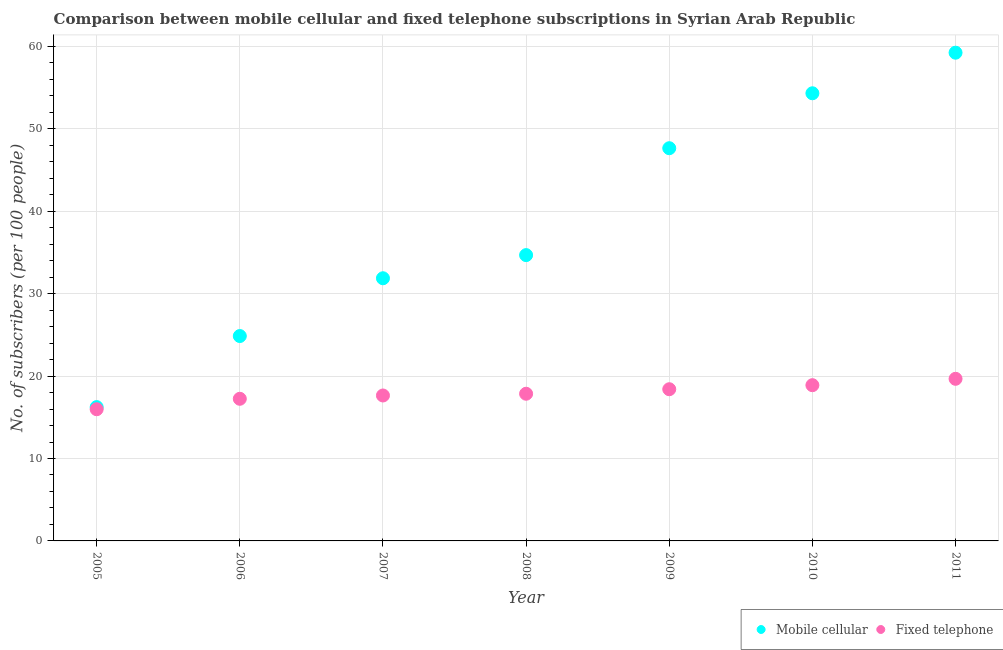How many different coloured dotlines are there?
Keep it short and to the point. 2. What is the number of mobile cellular subscribers in 2009?
Offer a terse response. 47.65. Across all years, what is the maximum number of mobile cellular subscribers?
Offer a terse response. 59.24. Across all years, what is the minimum number of mobile cellular subscribers?
Your answer should be very brief. 16.24. In which year was the number of mobile cellular subscribers maximum?
Your answer should be compact. 2011. In which year was the number of mobile cellular subscribers minimum?
Your response must be concise. 2005. What is the total number of mobile cellular subscribers in the graph?
Make the answer very short. 268.86. What is the difference between the number of mobile cellular subscribers in 2005 and that in 2006?
Your answer should be very brief. -8.62. What is the difference between the number of mobile cellular subscribers in 2011 and the number of fixed telephone subscribers in 2010?
Offer a terse response. 40.34. What is the average number of fixed telephone subscribers per year?
Offer a terse response. 17.96. In the year 2007, what is the difference between the number of mobile cellular subscribers and number of fixed telephone subscribers?
Keep it short and to the point. 14.23. What is the ratio of the number of mobile cellular subscribers in 2008 to that in 2010?
Give a very brief answer. 0.64. Is the number of fixed telephone subscribers in 2006 less than that in 2007?
Give a very brief answer. Yes. Is the difference between the number of mobile cellular subscribers in 2007 and 2009 greater than the difference between the number of fixed telephone subscribers in 2007 and 2009?
Keep it short and to the point. No. What is the difference between the highest and the second highest number of fixed telephone subscribers?
Offer a very short reply. 0.77. What is the difference between the highest and the lowest number of mobile cellular subscribers?
Provide a short and direct response. 43. Does the number of fixed telephone subscribers monotonically increase over the years?
Ensure brevity in your answer.  Yes. How many dotlines are there?
Keep it short and to the point. 2. How many years are there in the graph?
Provide a succinct answer. 7. Where does the legend appear in the graph?
Offer a terse response. Bottom right. What is the title of the graph?
Offer a very short reply. Comparison between mobile cellular and fixed telephone subscriptions in Syrian Arab Republic. Does "Agricultural land" appear as one of the legend labels in the graph?
Keep it short and to the point. No. What is the label or title of the Y-axis?
Make the answer very short. No. of subscribers (per 100 people). What is the No. of subscribers (per 100 people) of Mobile cellular in 2005?
Offer a terse response. 16.24. What is the No. of subscribers (per 100 people) in Fixed telephone in 2005?
Offer a terse response. 15.98. What is the No. of subscribers (per 100 people) of Mobile cellular in 2006?
Provide a succinct answer. 24.86. What is the No. of subscribers (per 100 people) of Fixed telephone in 2006?
Your answer should be very brief. 17.25. What is the No. of subscribers (per 100 people) of Mobile cellular in 2007?
Keep it short and to the point. 31.87. What is the No. of subscribers (per 100 people) in Fixed telephone in 2007?
Your answer should be compact. 17.65. What is the No. of subscribers (per 100 people) of Mobile cellular in 2008?
Your response must be concise. 34.68. What is the No. of subscribers (per 100 people) of Fixed telephone in 2008?
Give a very brief answer. 17.86. What is the No. of subscribers (per 100 people) in Mobile cellular in 2009?
Keep it short and to the point. 47.65. What is the No. of subscribers (per 100 people) of Fixed telephone in 2009?
Offer a very short reply. 18.41. What is the No. of subscribers (per 100 people) in Mobile cellular in 2010?
Ensure brevity in your answer.  54.32. What is the No. of subscribers (per 100 people) in Fixed telephone in 2010?
Your answer should be compact. 18.9. What is the No. of subscribers (per 100 people) in Mobile cellular in 2011?
Provide a succinct answer. 59.24. What is the No. of subscribers (per 100 people) of Fixed telephone in 2011?
Ensure brevity in your answer.  19.67. Across all years, what is the maximum No. of subscribers (per 100 people) of Mobile cellular?
Your response must be concise. 59.24. Across all years, what is the maximum No. of subscribers (per 100 people) in Fixed telephone?
Ensure brevity in your answer.  19.67. Across all years, what is the minimum No. of subscribers (per 100 people) in Mobile cellular?
Provide a short and direct response. 16.24. Across all years, what is the minimum No. of subscribers (per 100 people) in Fixed telephone?
Ensure brevity in your answer.  15.98. What is the total No. of subscribers (per 100 people) in Mobile cellular in the graph?
Your answer should be very brief. 268.86. What is the total No. of subscribers (per 100 people) in Fixed telephone in the graph?
Offer a terse response. 125.7. What is the difference between the No. of subscribers (per 100 people) in Mobile cellular in 2005 and that in 2006?
Ensure brevity in your answer.  -8.62. What is the difference between the No. of subscribers (per 100 people) of Fixed telephone in 2005 and that in 2006?
Provide a succinct answer. -1.27. What is the difference between the No. of subscribers (per 100 people) in Mobile cellular in 2005 and that in 2007?
Your answer should be compact. -15.63. What is the difference between the No. of subscribers (per 100 people) in Fixed telephone in 2005 and that in 2007?
Offer a terse response. -1.67. What is the difference between the No. of subscribers (per 100 people) of Mobile cellular in 2005 and that in 2008?
Offer a terse response. -18.44. What is the difference between the No. of subscribers (per 100 people) in Fixed telephone in 2005 and that in 2008?
Provide a short and direct response. -1.88. What is the difference between the No. of subscribers (per 100 people) of Mobile cellular in 2005 and that in 2009?
Offer a very short reply. -31.41. What is the difference between the No. of subscribers (per 100 people) in Fixed telephone in 2005 and that in 2009?
Give a very brief answer. -2.43. What is the difference between the No. of subscribers (per 100 people) of Mobile cellular in 2005 and that in 2010?
Offer a terse response. -38.08. What is the difference between the No. of subscribers (per 100 people) in Fixed telephone in 2005 and that in 2010?
Provide a succinct answer. -2.92. What is the difference between the No. of subscribers (per 100 people) in Mobile cellular in 2005 and that in 2011?
Provide a succinct answer. -43. What is the difference between the No. of subscribers (per 100 people) of Fixed telephone in 2005 and that in 2011?
Your response must be concise. -3.69. What is the difference between the No. of subscribers (per 100 people) of Mobile cellular in 2006 and that in 2007?
Provide a short and direct response. -7.01. What is the difference between the No. of subscribers (per 100 people) of Fixed telephone in 2006 and that in 2007?
Offer a very short reply. -0.4. What is the difference between the No. of subscribers (per 100 people) of Mobile cellular in 2006 and that in 2008?
Offer a very short reply. -9.82. What is the difference between the No. of subscribers (per 100 people) in Fixed telephone in 2006 and that in 2008?
Your answer should be compact. -0.61. What is the difference between the No. of subscribers (per 100 people) of Mobile cellular in 2006 and that in 2009?
Your answer should be very brief. -22.79. What is the difference between the No. of subscribers (per 100 people) of Fixed telephone in 2006 and that in 2009?
Your answer should be compact. -1.16. What is the difference between the No. of subscribers (per 100 people) in Mobile cellular in 2006 and that in 2010?
Keep it short and to the point. -29.46. What is the difference between the No. of subscribers (per 100 people) of Fixed telephone in 2006 and that in 2010?
Provide a short and direct response. -1.65. What is the difference between the No. of subscribers (per 100 people) in Mobile cellular in 2006 and that in 2011?
Your answer should be compact. -34.38. What is the difference between the No. of subscribers (per 100 people) in Fixed telephone in 2006 and that in 2011?
Give a very brief answer. -2.42. What is the difference between the No. of subscribers (per 100 people) in Mobile cellular in 2007 and that in 2008?
Offer a very short reply. -2.81. What is the difference between the No. of subscribers (per 100 people) in Fixed telephone in 2007 and that in 2008?
Offer a terse response. -0.21. What is the difference between the No. of subscribers (per 100 people) in Mobile cellular in 2007 and that in 2009?
Offer a very short reply. -15.78. What is the difference between the No. of subscribers (per 100 people) of Fixed telephone in 2007 and that in 2009?
Your answer should be very brief. -0.76. What is the difference between the No. of subscribers (per 100 people) of Mobile cellular in 2007 and that in 2010?
Provide a succinct answer. -22.45. What is the difference between the No. of subscribers (per 100 people) in Fixed telephone in 2007 and that in 2010?
Your answer should be compact. -1.25. What is the difference between the No. of subscribers (per 100 people) of Mobile cellular in 2007 and that in 2011?
Provide a short and direct response. -27.37. What is the difference between the No. of subscribers (per 100 people) in Fixed telephone in 2007 and that in 2011?
Give a very brief answer. -2.02. What is the difference between the No. of subscribers (per 100 people) of Mobile cellular in 2008 and that in 2009?
Keep it short and to the point. -12.97. What is the difference between the No. of subscribers (per 100 people) of Fixed telephone in 2008 and that in 2009?
Your response must be concise. -0.55. What is the difference between the No. of subscribers (per 100 people) of Mobile cellular in 2008 and that in 2010?
Ensure brevity in your answer.  -19.64. What is the difference between the No. of subscribers (per 100 people) in Fixed telephone in 2008 and that in 2010?
Offer a very short reply. -1.04. What is the difference between the No. of subscribers (per 100 people) in Mobile cellular in 2008 and that in 2011?
Ensure brevity in your answer.  -24.56. What is the difference between the No. of subscribers (per 100 people) of Fixed telephone in 2008 and that in 2011?
Provide a short and direct response. -1.81. What is the difference between the No. of subscribers (per 100 people) of Mobile cellular in 2009 and that in 2010?
Make the answer very short. -6.67. What is the difference between the No. of subscribers (per 100 people) in Fixed telephone in 2009 and that in 2010?
Your answer should be very brief. -0.49. What is the difference between the No. of subscribers (per 100 people) in Mobile cellular in 2009 and that in 2011?
Your answer should be very brief. -11.59. What is the difference between the No. of subscribers (per 100 people) in Fixed telephone in 2009 and that in 2011?
Ensure brevity in your answer.  -1.26. What is the difference between the No. of subscribers (per 100 people) in Mobile cellular in 2010 and that in 2011?
Provide a short and direct response. -4.92. What is the difference between the No. of subscribers (per 100 people) of Fixed telephone in 2010 and that in 2011?
Your answer should be compact. -0.77. What is the difference between the No. of subscribers (per 100 people) of Mobile cellular in 2005 and the No. of subscribers (per 100 people) of Fixed telephone in 2006?
Provide a succinct answer. -1.01. What is the difference between the No. of subscribers (per 100 people) in Mobile cellular in 2005 and the No. of subscribers (per 100 people) in Fixed telephone in 2007?
Your response must be concise. -1.41. What is the difference between the No. of subscribers (per 100 people) in Mobile cellular in 2005 and the No. of subscribers (per 100 people) in Fixed telephone in 2008?
Make the answer very short. -1.62. What is the difference between the No. of subscribers (per 100 people) in Mobile cellular in 2005 and the No. of subscribers (per 100 people) in Fixed telephone in 2009?
Your response must be concise. -2.17. What is the difference between the No. of subscribers (per 100 people) of Mobile cellular in 2005 and the No. of subscribers (per 100 people) of Fixed telephone in 2010?
Offer a terse response. -2.66. What is the difference between the No. of subscribers (per 100 people) in Mobile cellular in 2005 and the No. of subscribers (per 100 people) in Fixed telephone in 2011?
Your answer should be very brief. -3.43. What is the difference between the No. of subscribers (per 100 people) in Mobile cellular in 2006 and the No. of subscribers (per 100 people) in Fixed telephone in 2007?
Provide a succinct answer. 7.21. What is the difference between the No. of subscribers (per 100 people) of Mobile cellular in 2006 and the No. of subscribers (per 100 people) of Fixed telephone in 2008?
Your answer should be very brief. 7. What is the difference between the No. of subscribers (per 100 people) of Mobile cellular in 2006 and the No. of subscribers (per 100 people) of Fixed telephone in 2009?
Offer a terse response. 6.45. What is the difference between the No. of subscribers (per 100 people) in Mobile cellular in 2006 and the No. of subscribers (per 100 people) in Fixed telephone in 2010?
Provide a short and direct response. 5.96. What is the difference between the No. of subscribers (per 100 people) of Mobile cellular in 2006 and the No. of subscribers (per 100 people) of Fixed telephone in 2011?
Your response must be concise. 5.19. What is the difference between the No. of subscribers (per 100 people) in Mobile cellular in 2007 and the No. of subscribers (per 100 people) in Fixed telephone in 2008?
Your answer should be very brief. 14.01. What is the difference between the No. of subscribers (per 100 people) of Mobile cellular in 2007 and the No. of subscribers (per 100 people) of Fixed telephone in 2009?
Offer a terse response. 13.47. What is the difference between the No. of subscribers (per 100 people) of Mobile cellular in 2007 and the No. of subscribers (per 100 people) of Fixed telephone in 2010?
Your answer should be very brief. 12.98. What is the difference between the No. of subscribers (per 100 people) in Mobile cellular in 2007 and the No. of subscribers (per 100 people) in Fixed telephone in 2011?
Make the answer very short. 12.2. What is the difference between the No. of subscribers (per 100 people) of Mobile cellular in 2008 and the No. of subscribers (per 100 people) of Fixed telephone in 2009?
Give a very brief answer. 16.27. What is the difference between the No. of subscribers (per 100 people) in Mobile cellular in 2008 and the No. of subscribers (per 100 people) in Fixed telephone in 2010?
Give a very brief answer. 15.78. What is the difference between the No. of subscribers (per 100 people) of Mobile cellular in 2008 and the No. of subscribers (per 100 people) of Fixed telephone in 2011?
Give a very brief answer. 15.01. What is the difference between the No. of subscribers (per 100 people) of Mobile cellular in 2009 and the No. of subscribers (per 100 people) of Fixed telephone in 2010?
Provide a succinct answer. 28.75. What is the difference between the No. of subscribers (per 100 people) in Mobile cellular in 2009 and the No. of subscribers (per 100 people) in Fixed telephone in 2011?
Offer a very short reply. 27.98. What is the difference between the No. of subscribers (per 100 people) of Mobile cellular in 2010 and the No. of subscribers (per 100 people) of Fixed telephone in 2011?
Provide a short and direct response. 34.65. What is the average No. of subscribers (per 100 people) of Mobile cellular per year?
Offer a very short reply. 38.41. What is the average No. of subscribers (per 100 people) of Fixed telephone per year?
Your answer should be compact. 17.96. In the year 2005, what is the difference between the No. of subscribers (per 100 people) in Mobile cellular and No. of subscribers (per 100 people) in Fixed telephone?
Your answer should be very brief. 0.26. In the year 2006, what is the difference between the No. of subscribers (per 100 people) in Mobile cellular and No. of subscribers (per 100 people) in Fixed telephone?
Provide a succinct answer. 7.62. In the year 2007, what is the difference between the No. of subscribers (per 100 people) of Mobile cellular and No. of subscribers (per 100 people) of Fixed telephone?
Keep it short and to the point. 14.23. In the year 2008, what is the difference between the No. of subscribers (per 100 people) in Mobile cellular and No. of subscribers (per 100 people) in Fixed telephone?
Give a very brief answer. 16.82. In the year 2009, what is the difference between the No. of subscribers (per 100 people) of Mobile cellular and No. of subscribers (per 100 people) of Fixed telephone?
Make the answer very short. 29.25. In the year 2010, what is the difference between the No. of subscribers (per 100 people) in Mobile cellular and No. of subscribers (per 100 people) in Fixed telephone?
Offer a very short reply. 35.42. In the year 2011, what is the difference between the No. of subscribers (per 100 people) in Mobile cellular and No. of subscribers (per 100 people) in Fixed telephone?
Make the answer very short. 39.57. What is the ratio of the No. of subscribers (per 100 people) in Mobile cellular in 2005 to that in 2006?
Your response must be concise. 0.65. What is the ratio of the No. of subscribers (per 100 people) in Fixed telephone in 2005 to that in 2006?
Give a very brief answer. 0.93. What is the ratio of the No. of subscribers (per 100 people) of Mobile cellular in 2005 to that in 2007?
Your answer should be compact. 0.51. What is the ratio of the No. of subscribers (per 100 people) in Fixed telephone in 2005 to that in 2007?
Keep it short and to the point. 0.91. What is the ratio of the No. of subscribers (per 100 people) in Mobile cellular in 2005 to that in 2008?
Your answer should be very brief. 0.47. What is the ratio of the No. of subscribers (per 100 people) in Fixed telephone in 2005 to that in 2008?
Offer a terse response. 0.89. What is the ratio of the No. of subscribers (per 100 people) in Mobile cellular in 2005 to that in 2009?
Your response must be concise. 0.34. What is the ratio of the No. of subscribers (per 100 people) in Fixed telephone in 2005 to that in 2009?
Make the answer very short. 0.87. What is the ratio of the No. of subscribers (per 100 people) of Mobile cellular in 2005 to that in 2010?
Provide a succinct answer. 0.3. What is the ratio of the No. of subscribers (per 100 people) of Fixed telephone in 2005 to that in 2010?
Your answer should be very brief. 0.85. What is the ratio of the No. of subscribers (per 100 people) of Mobile cellular in 2005 to that in 2011?
Offer a terse response. 0.27. What is the ratio of the No. of subscribers (per 100 people) in Fixed telephone in 2005 to that in 2011?
Give a very brief answer. 0.81. What is the ratio of the No. of subscribers (per 100 people) in Mobile cellular in 2006 to that in 2007?
Give a very brief answer. 0.78. What is the ratio of the No. of subscribers (per 100 people) of Fixed telephone in 2006 to that in 2007?
Keep it short and to the point. 0.98. What is the ratio of the No. of subscribers (per 100 people) in Mobile cellular in 2006 to that in 2008?
Provide a short and direct response. 0.72. What is the ratio of the No. of subscribers (per 100 people) of Fixed telephone in 2006 to that in 2008?
Your response must be concise. 0.97. What is the ratio of the No. of subscribers (per 100 people) of Mobile cellular in 2006 to that in 2009?
Provide a short and direct response. 0.52. What is the ratio of the No. of subscribers (per 100 people) of Fixed telephone in 2006 to that in 2009?
Your response must be concise. 0.94. What is the ratio of the No. of subscribers (per 100 people) of Mobile cellular in 2006 to that in 2010?
Ensure brevity in your answer.  0.46. What is the ratio of the No. of subscribers (per 100 people) of Fixed telephone in 2006 to that in 2010?
Give a very brief answer. 0.91. What is the ratio of the No. of subscribers (per 100 people) in Mobile cellular in 2006 to that in 2011?
Provide a succinct answer. 0.42. What is the ratio of the No. of subscribers (per 100 people) in Fixed telephone in 2006 to that in 2011?
Your response must be concise. 0.88. What is the ratio of the No. of subscribers (per 100 people) of Mobile cellular in 2007 to that in 2008?
Your answer should be very brief. 0.92. What is the ratio of the No. of subscribers (per 100 people) in Mobile cellular in 2007 to that in 2009?
Your answer should be very brief. 0.67. What is the ratio of the No. of subscribers (per 100 people) of Fixed telephone in 2007 to that in 2009?
Offer a very short reply. 0.96. What is the ratio of the No. of subscribers (per 100 people) of Mobile cellular in 2007 to that in 2010?
Provide a succinct answer. 0.59. What is the ratio of the No. of subscribers (per 100 people) in Fixed telephone in 2007 to that in 2010?
Offer a terse response. 0.93. What is the ratio of the No. of subscribers (per 100 people) of Mobile cellular in 2007 to that in 2011?
Your answer should be compact. 0.54. What is the ratio of the No. of subscribers (per 100 people) in Fixed telephone in 2007 to that in 2011?
Make the answer very short. 0.9. What is the ratio of the No. of subscribers (per 100 people) of Mobile cellular in 2008 to that in 2009?
Ensure brevity in your answer.  0.73. What is the ratio of the No. of subscribers (per 100 people) in Fixed telephone in 2008 to that in 2009?
Keep it short and to the point. 0.97. What is the ratio of the No. of subscribers (per 100 people) of Mobile cellular in 2008 to that in 2010?
Provide a succinct answer. 0.64. What is the ratio of the No. of subscribers (per 100 people) of Fixed telephone in 2008 to that in 2010?
Keep it short and to the point. 0.94. What is the ratio of the No. of subscribers (per 100 people) in Mobile cellular in 2008 to that in 2011?
Your answer should be compact. 0.59. What is the ratio of the No. of subscribers (per 100 people) of Fixed telephone in 2008 to that in 2011?
Keep it short and to the point. 0.91. What is the ratio of the No. of subscribers (per 100 people) of Mobile cellular in 2009 to that in 2010?
Your answer should be very brief. 0.88. What is the ratio of the No. of subscribers (per 100 people) of Fixed telephone in 2009 to that in 2010?
Offer a very short reply. 0.97. What is the ratio of the No. of subscribers (per 100 people) of Mobile cellular in 2009 to that in 2011?
Your response must be concise. 0.8. What is the ratio of the No. of subscribers (per 100 people) of Fixed telephone in 2009 to that in 2011?
Provide a short and direct response. 0.94. What is the ratio of the No. of subscribers (per 100 people) in Mobile cellular in 2010 to that in 2011?
Your answer should be very brief. 0.92. What is the ratio of the No. of subscribers (per 100 people) of Fixed telephone in 2010 to that in 2011?
Provide a succinct answer. 0.96. What is the difference between the highest and the second highest No. of subscribers (per 100 people) of Mobile cellular?
Give a very brief answer. 4.92. What is the difference between the highest and the second highest No. of subscribers (per 100 people) of Fixed telephone?
Offer a very short reply. 0.77. What is the difference between the highest and the lowest No. of subscribers (per 100 people) in Mobile cellular?
Offer a terse response. 43. What is the difference between the highest and the lowest No. of subscribers (per 100 people) of Fixed telephone?
Offer a very short reply. 3.69. 